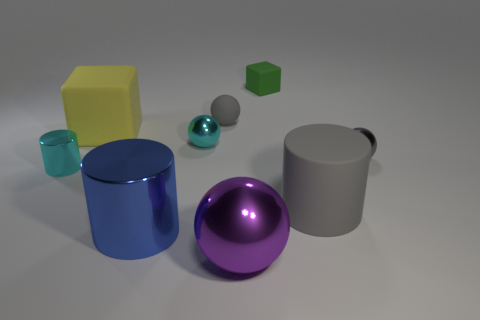What number of tiny objects are cyan shiny cylinders or brown metallic objects?
Ensure brevity in your answer.  1. What material is the big gray cylinder?
Keep it short and to the point. Rubber. How many other objects are there of the same shape as the small gray rubber object?
Your response must be concise. 3. How big is the yellow rubber block?
Provide a succinct answer. Large. How big is the cylinder that is both to the left of the big gray matte cylinder and on the right side of the tiny cylinder?
Provide a short and direct response. Large. What is the shape of the tiny cyan metallic object that is on the left side of the yellow object?
Provide a short and direct response. Cylinder. Is the material of the yellow cube the same as the small object behind the gray rubber ball?
Make the answer very short. Yes. Is the shape of the blue metallic thing the same as the yellow rubber object?
Provide a short and direct response. No. There is a cyan object that is the same shape as the large gray matte thing; what is it made of?
Your answer should be compact. Metal. There is a small thing that is in front of the gray matte ball and to the right of the small cyan shiny ball; what color is it?
Offer a very short reply. Gray. 